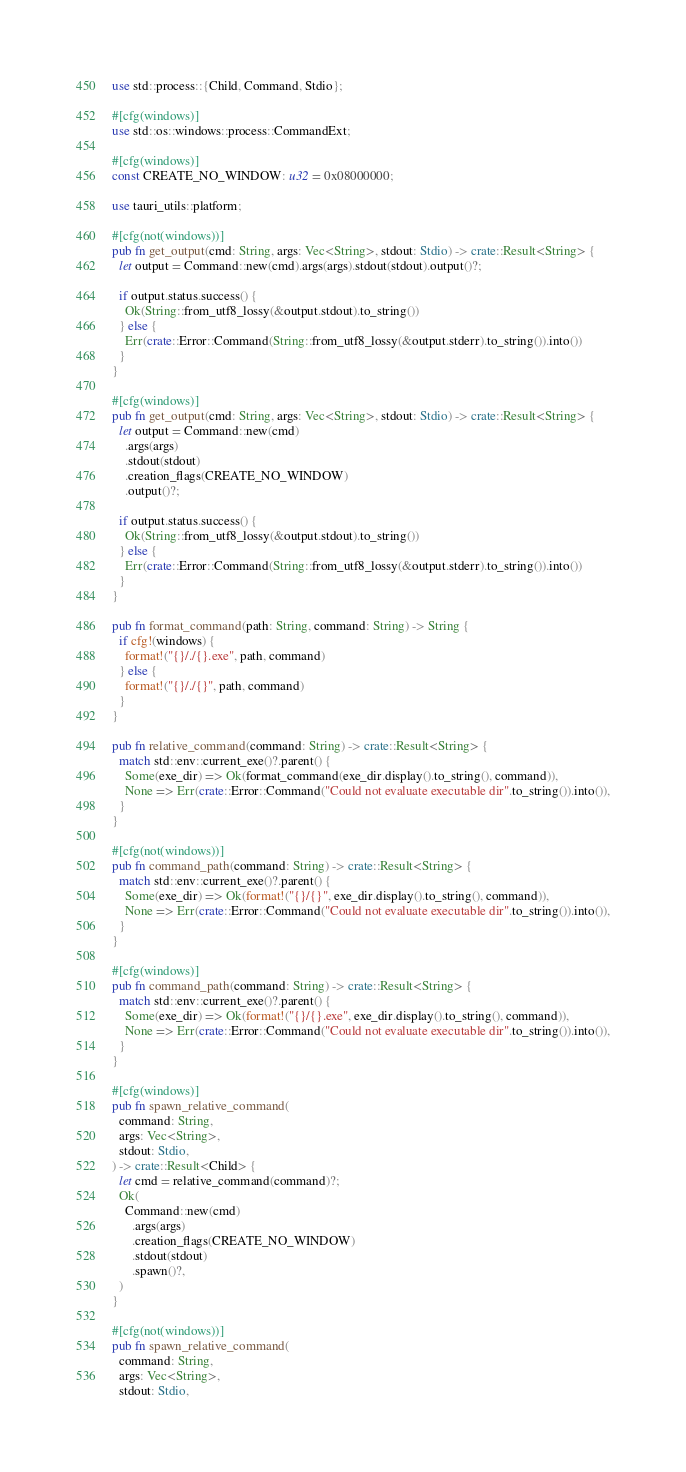Convert code to text. <code><loc_0><loc_0><loc_500><loc_500><_Rust_>use std::process::{Child, Command, Stdio};

#[cfg(windows)]
use std::os::windows::process::CommandExt;

#[cfg(windows)]
const CREATE_NO_WINDOW: u32 = 0x08000000;

use tauri_utils::platform;

#[cfg(not(windows))]
pub fn get_output(cmd: String, args: Vec<String>, stdout: Stdio) -> crate::Result<String> {
  let output = Command::new(cmd).args(args).stdout(stdout).output()?;

  if output.status.success() {
    Ok(String::from_utf8_lossy(&output.stdout).to_string())
  } else {
    Err(crate::Error::Command(String::from_utf8_lossy(&output.stderr).to_string()).into())
  }
}

#[cfg(windows)]
pub fn get_output(cmd: String, args: Vec<String>, stdout: Stdio) -> crate::Result<String> {
  let output = Command::new(cmd)
    .args(args)
    .stdout(stdout)
    .creation_flags(CREATE_NO_WINDOW)
    .output()?;

  if output.status.success() {
    Ok(String::from_utf8_lossy(&output.stdout).to_string())
  } else {
    Err(crate::Error::Command(String::from_utf8_lossy(&output.stderr).to_string()).into())
  }
}

pub fn format_command(path: String, command: String) -> String {
  if cfg!(windows) {
    format!("{}/./{}.exe", path, command)
  } else {
    format!("{}/./{}", path, command)
  }
}

pub fn relative_command(command: String) -> crate::Result<String> {
  match std::env::current_exe()?.parent() {
    Some(exe_dir) => Ok(format_command(exe_dir.display().to_string(), command)),
    None => Err(crate::Error::Command("Could not evaluate executable dir".to_string()).into()),
  }
}

#[cfg(not(windows))]
pub fn command_path(command: String) -> crate::Result<String> {
  match std::env::current_exe()?.parent() {
    Some(exe_dir) => Ok(format!("{}/{}", exe_dir.display().to_string(), command)),
    None => Err(crate::Error::Command("Could not evaluate executable dir".to_string()).into()),
  }
}

#[cfg(windows)]
pub fn command_path(command: String) -> crate::Result<String> {
  match std::env::current_exe()?.parent() {
    Some(exe_dir) => Ok(format!("{}/{}.exe", exe_dir.display().to_string(), command)),
    None => Err(crate::Error::Command("Could not evaluate executable dir".to_string()).into()),
  }
}

#[cfg(windows)]
pub fn spawn_relative_command(
  command: String,
  args: Vec<String>,
  stdout: Stdio,
) -> crate::Result<Child> {
  let cmd = relative_command(command)?;
  Ok(
    Command::new(cmd)
      .args(args)
      .creation_flags(CREATE_NO_WINDOW)
      .stdout(stdout)
      .spawn()?,
  )
}

#[cfg(not(windows))]
pub fn spawn_relative_command(
  command: String,
  args: Vec<String>,
  stdout: Stdio,</code> 